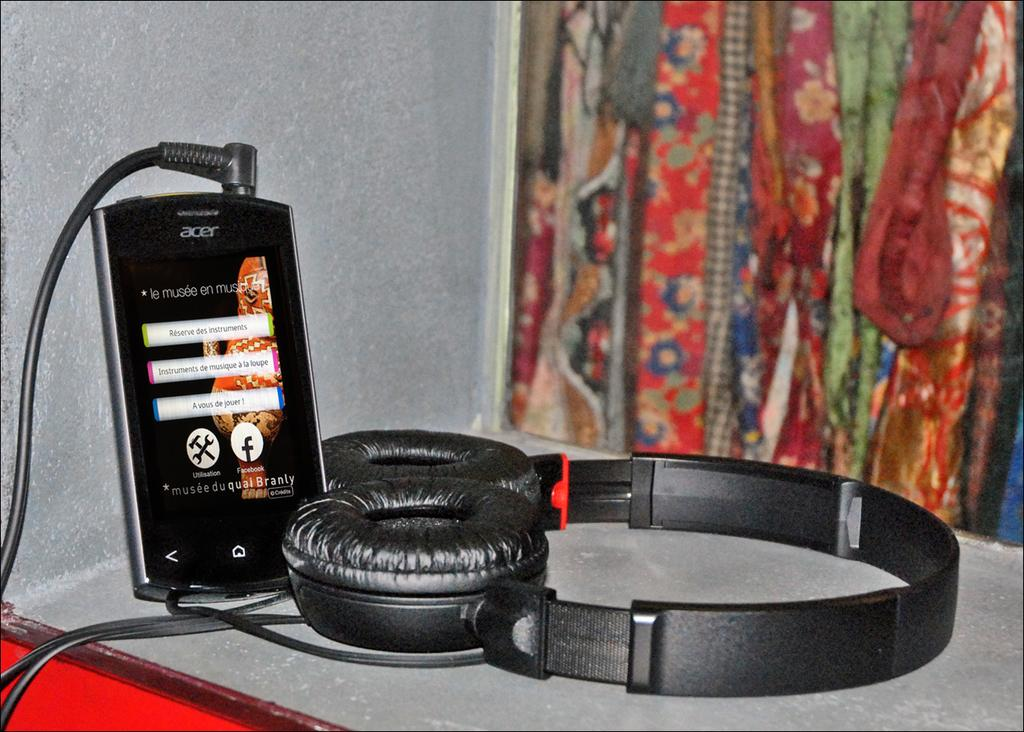<image>
Give a short and clear explanation of the subsequent image. Acer phone sits on a table hooked up to earphone 